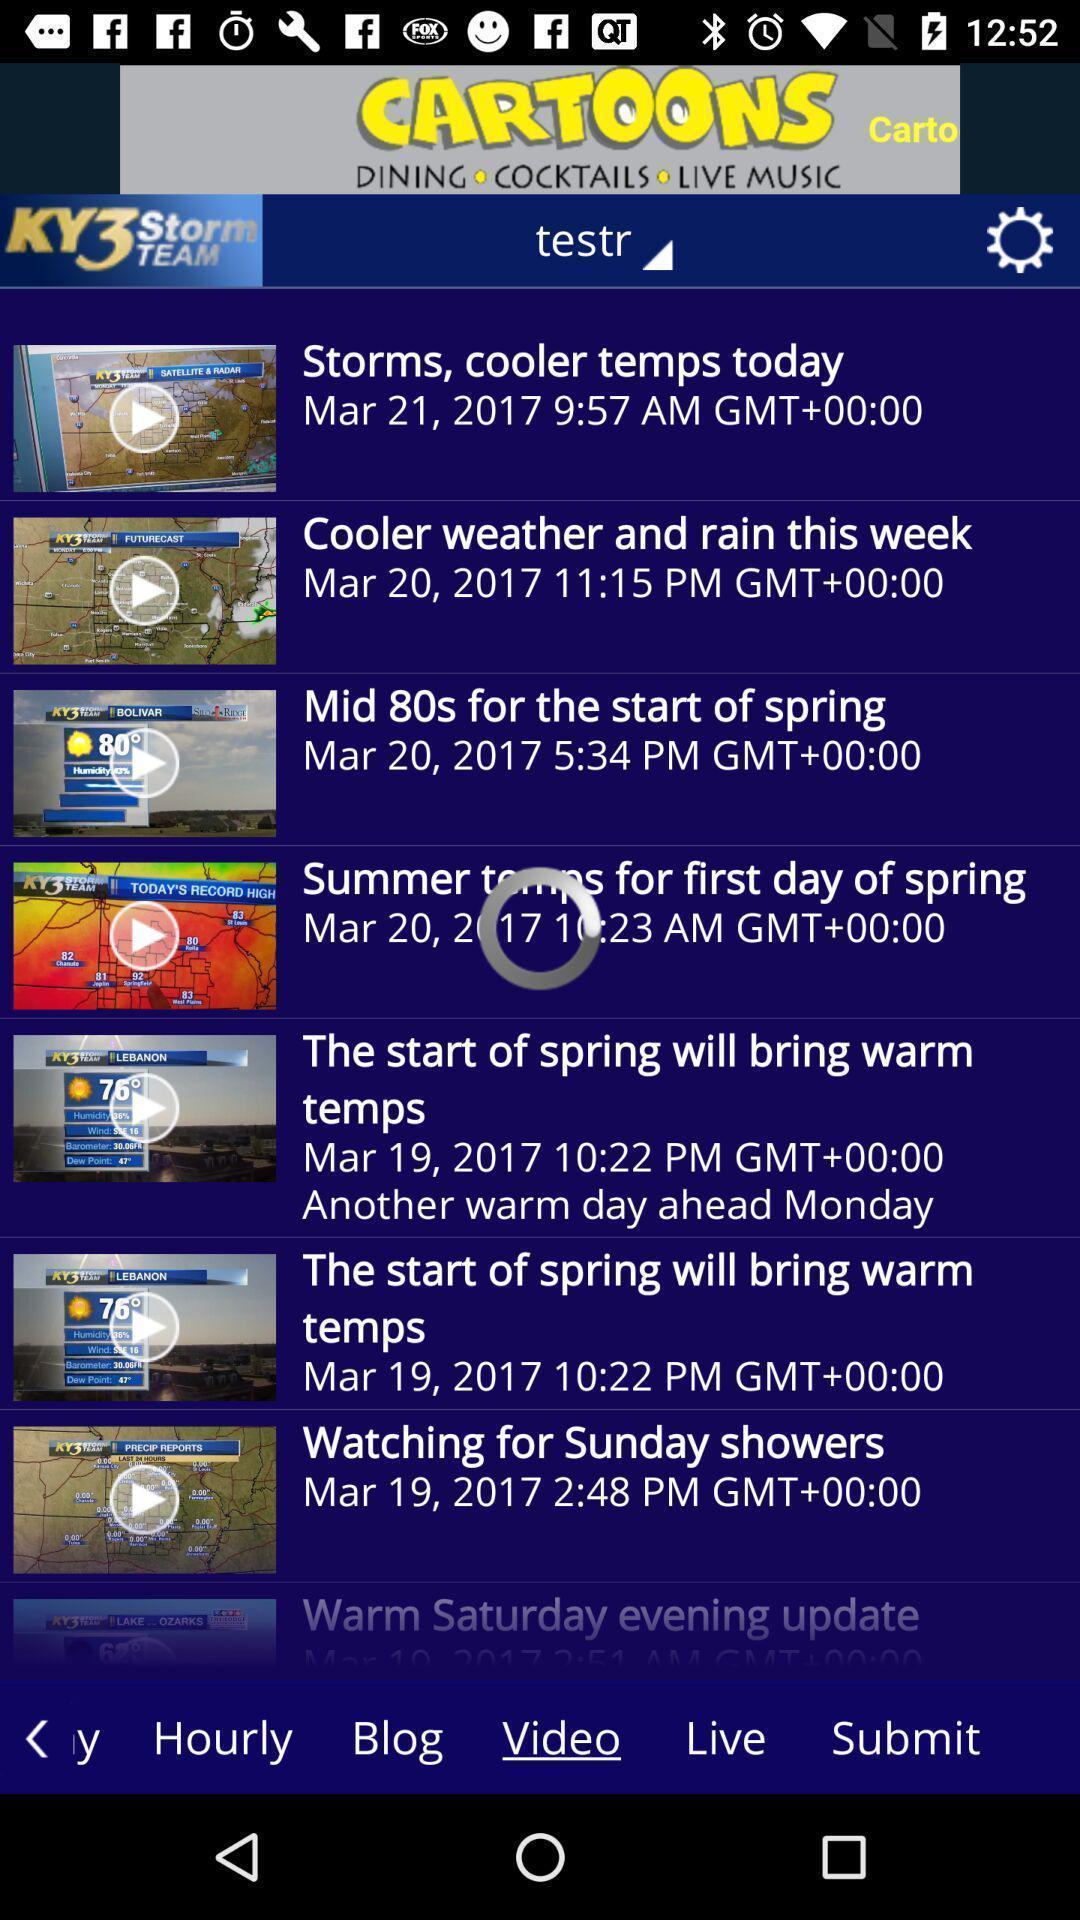Provide a detailed account of this screenshot. Screen shows list of videos in weather application. 